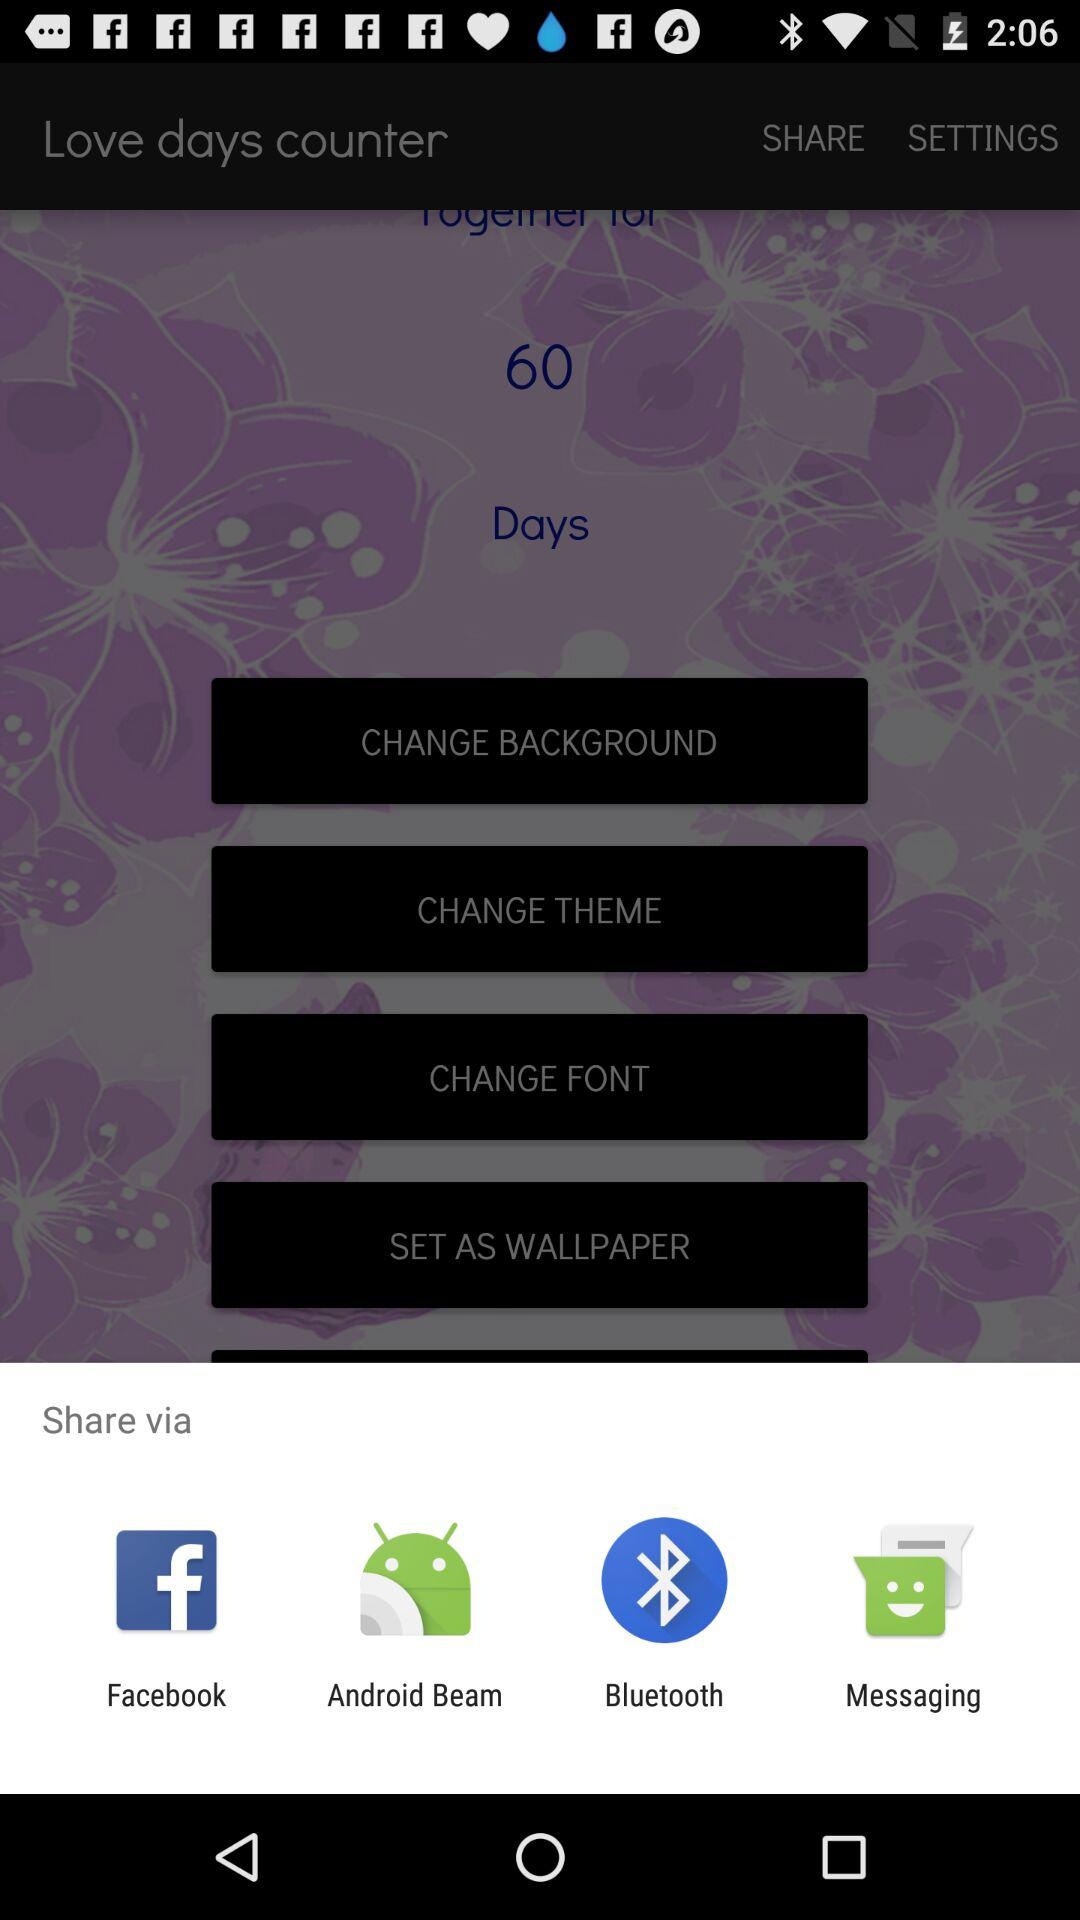Through what applications can we share? The applications are "Facebook", "Android Beam", "Bluetooth", and "Messaging". 